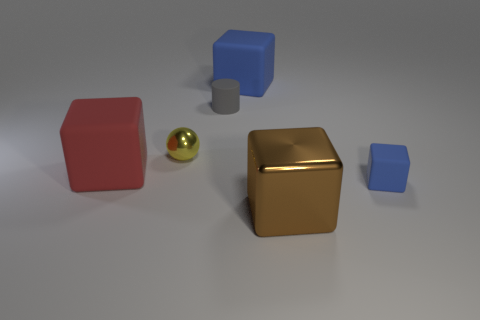Subtract all brown blocks. How many blocks are left? 3 Subtract 1 blocks. How many blocks are left? 3 Subtract all brown shiny blocks. How many blocks are left? 3 Add 4 blue rubber cubes. How many objects exist? 10 Subtract all gray cubes. Subtract all yellow cylinders. How many cubes are left? 4 Subtract all spheres. How many objects are left? 5 Subtract all metallic spheres. Subtract all blue rubber cubes. How many objects are left? 3 Add 3 rubber blocks. How many rubber blocks are left? 6 Add 2 gray matte objects. How many gray matte objects exist? 3 Subtract 0 blue spheres. How many objects are left? 6 